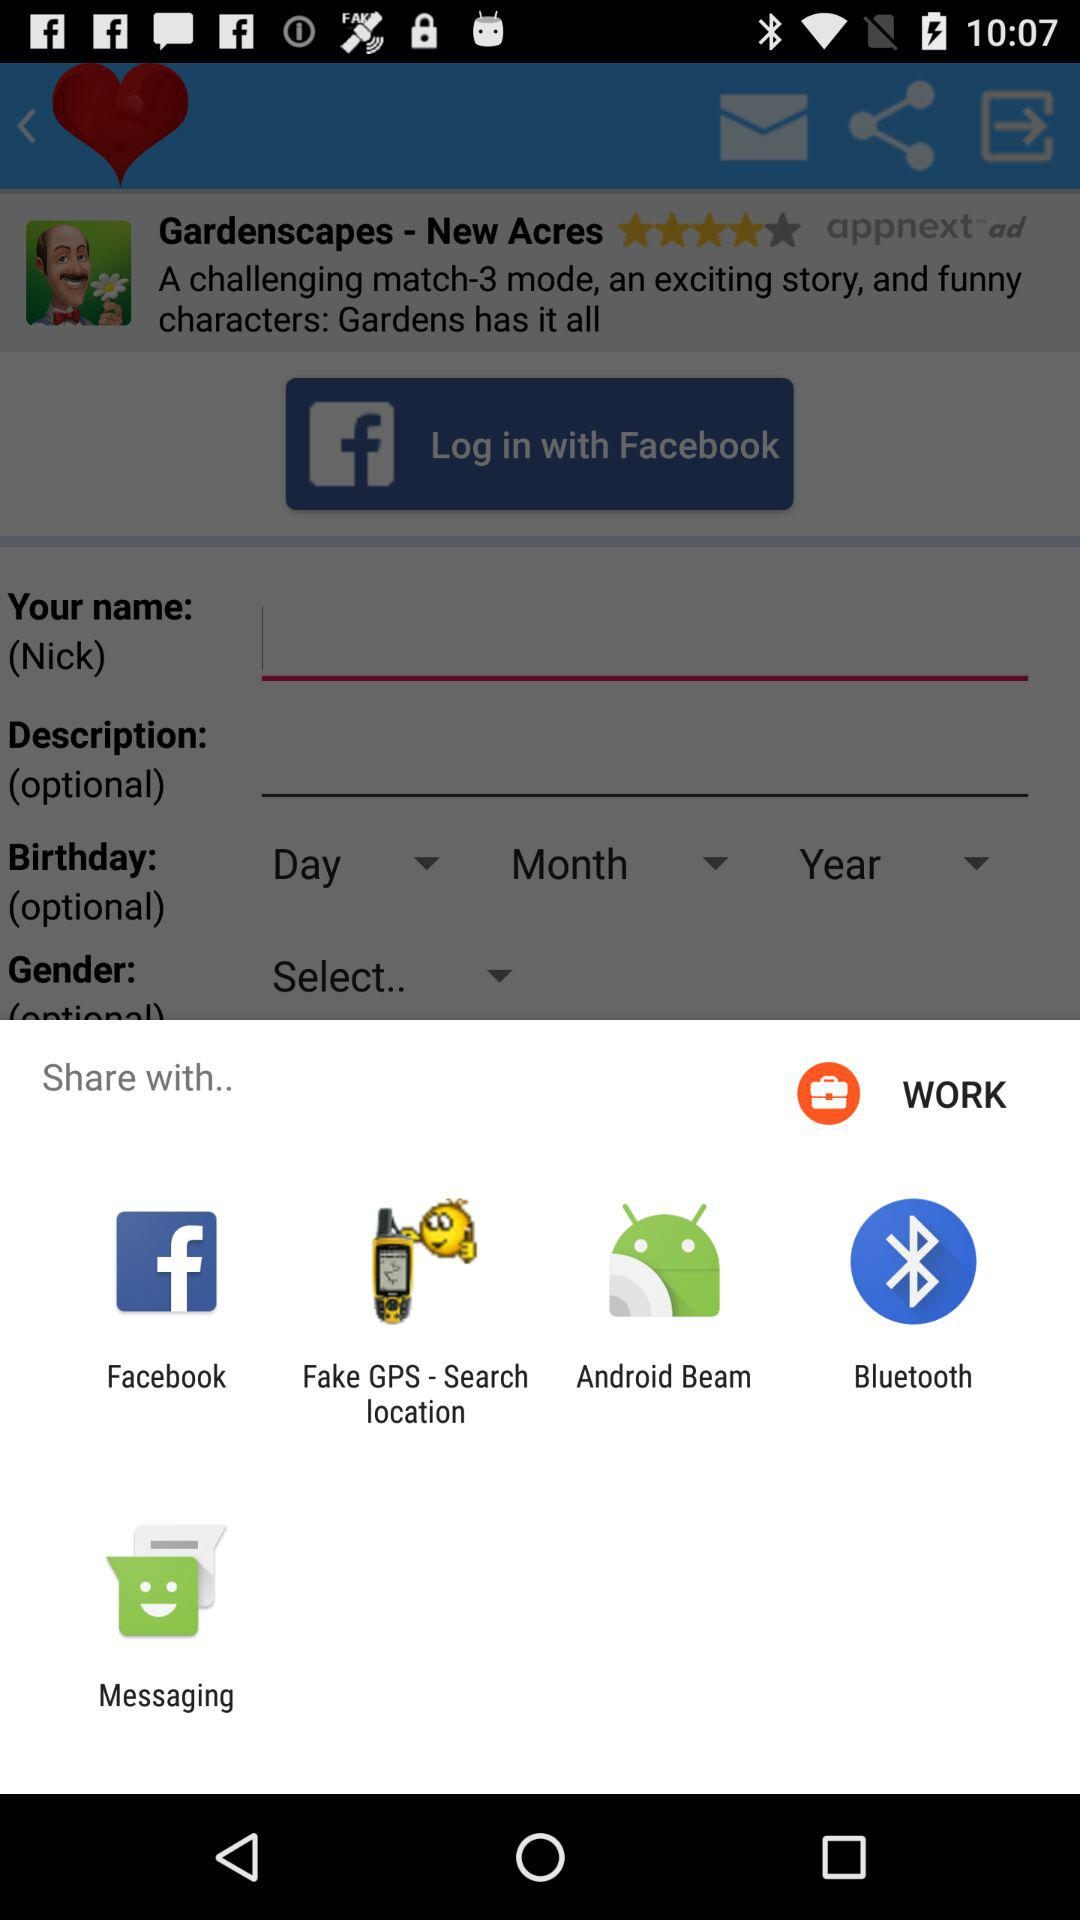When is the user's birthday?
When the provided information is insufficient, respond with <no answer>. <no answer> 